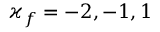Convert formula to latex. <formula><loc_0><loc_0><loc_500><loc_500>\varkappa _ { f } = - 2 , - 1 , 1</formula> 